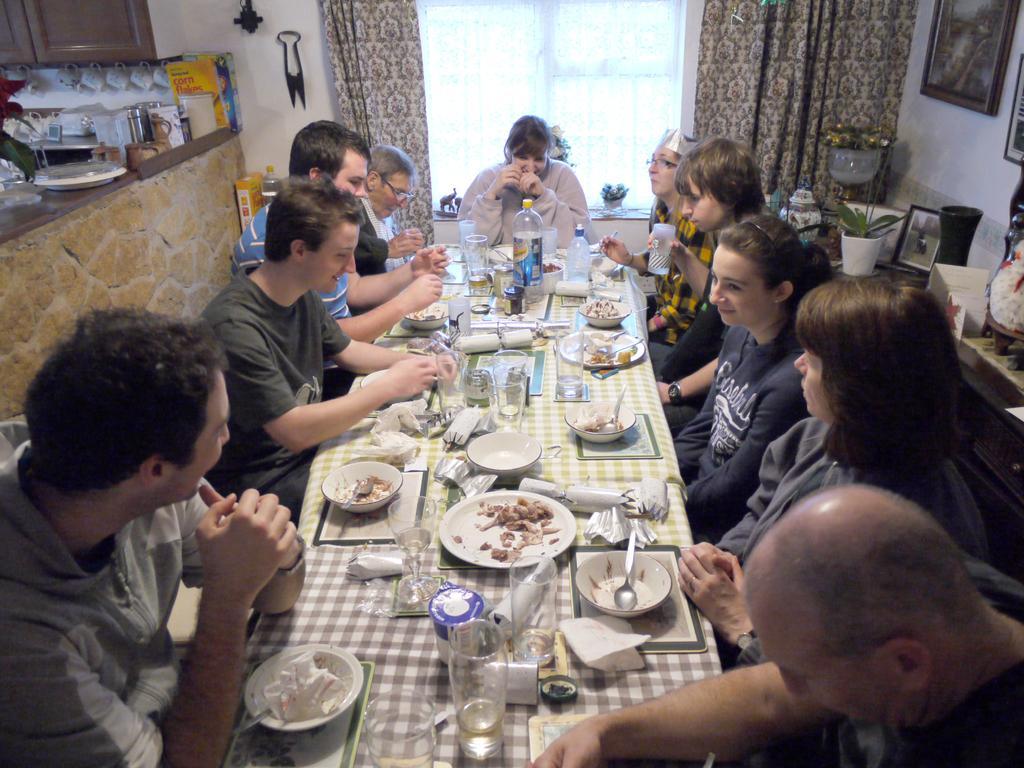Could you give a brief overview of what you see in this image? It is a kitchen, there is a big table few people are sitting around the table,they are having the food kept on the table, to the left side there is a kitchen wall and some utensils above it there is a cupboard, to the right side there is a wall beside the the wall there is window and curtains on the either side, beside that there are few photo frames to the wall. 